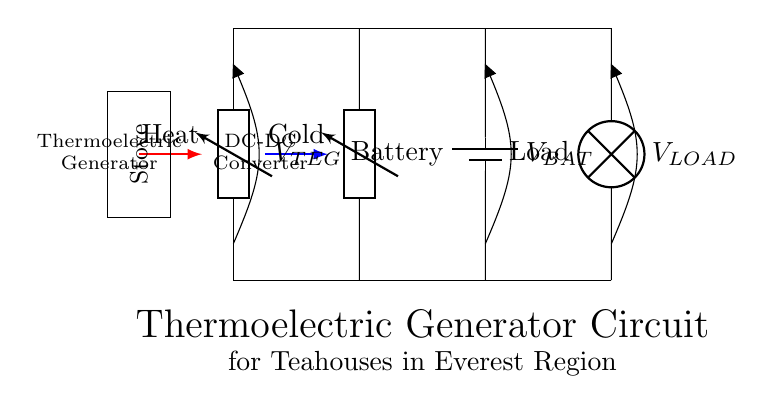What is the main component that converts heat into electricity? The main component that converts heat into electricity is the Thermoelectric Generator, shown at the left of the circuit. It uses temperature differences to generate electrical power.
Answer: Thermoelectric Generator What is the purpose of the DC-DC converter in this circuit? The DC-DC converter takes the variable voltage from the Thermoelectric Generator and stabilizes it to a usable level for the battery and load. This ensures consistent power delivery regardless of variations in temperature.
Answer: Stabilization of voltage What type of load is represented in this circuit? The load represented in this circuit is a lamp, indicated at the right end of the diagram. It consumes the electrical energy generated to provide light.
Answer: Lamp What is indicated by the labels V_TEG, V_BAT, and V_LOAD? V_TEG, V_BAT, and V_LOAD indicate the voltage measurements across the Thermoelectric Generator, the battery, and the load respectively. These measurements help in understanding how much voltage is available at each stage of the circuit.
Answer: Voltage measurements How does the system utilize the waste heat? The system utilizes the waste heat by channeling it from the stove to the Thermoelectric Generator, where the heat difference generates electricity that can power devices or charge a battery. Without this temperature gradient, the generator wouldn't produce electricity.
Answer: Waste heat to electricity What does the red arrow indicate in this circuit? The red arrow indicates the flow of heat from the stove to the Thermoelectric Generator. This highlights the input of heat, which is essential for the generator's operation.
Answer: Heat flow What is the role of the battery in this circuit? The battery stores the electrical energy generated by the Thermoelectric Generator for later use, allowing for a stable power supply even when the generator is not producing electricity. It acts as a buffer between generation and consumption.
Answer: Energy storage 